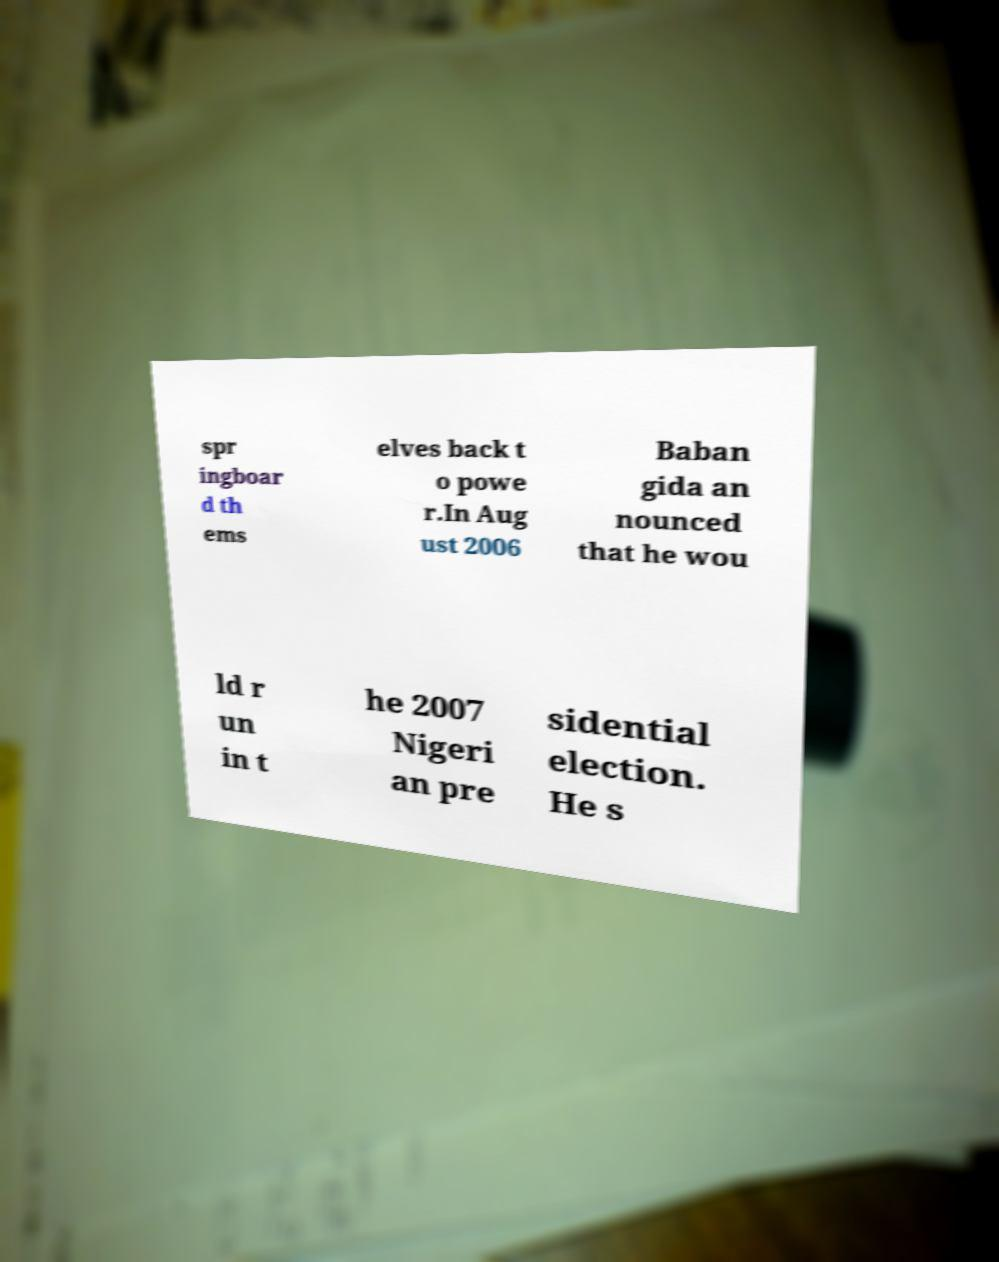Please read and relay the text visible in this image. What does it say? spr ingboar d th ems elves back t o powe r.In Aug ust 2006 Baban gida an nounced that he wou ld r un in t he 2007 Nigeri an pre sidential election. He s 